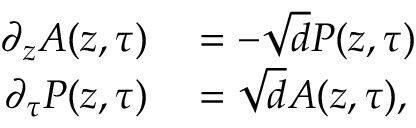<formula> <loc_0><loc_0><loc_500><loc_500>\begin{array} { r l } { \partial _ { z } A ( z , \tau ) } & = - \sqrt { d } P ( z , \tau ) } \\ { \partial _ { \tau } P ( z , \tau ) } & = \sqrt { d } A ( z , \tau ) , } \end{array}</formula> 